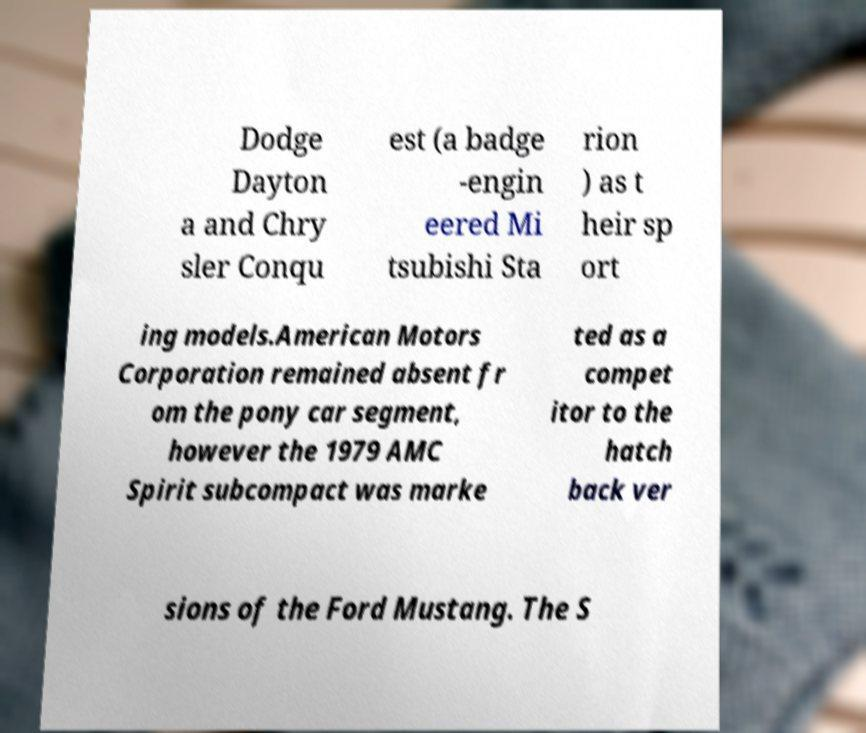Can you read and provide the text displayed in the image?This photo seems to have some interesting text. Can you extract and type it out for me? Dodge Dayton a and Chry sler Conqu est (a badge -engin eered Mi tsubishi Sta rion ) as t heir sp ort ing models.American Motors Corporation remained absent fr om the pony car segment, however the 1979 AMC Spirit subcompact was marke ted as a compet itor to the hatch back ver sions of the Ford Mustang. The S 